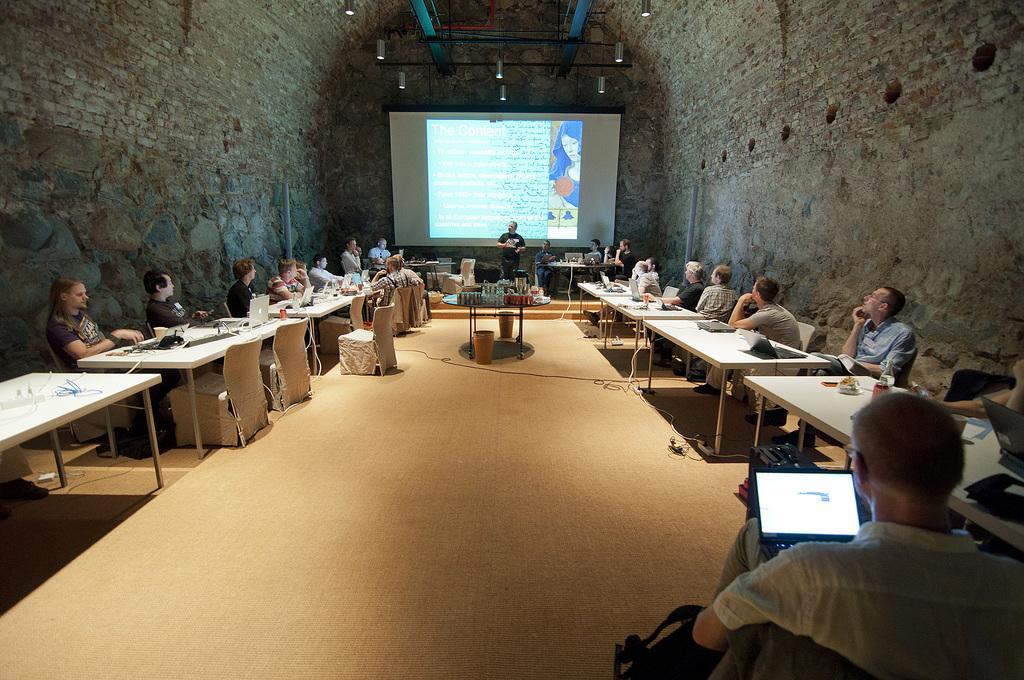Can you describe this image briefly? This picture shows a group people seated on the chairs and we see few laptops on the table and we see a projector screen and a man speaking by standing 